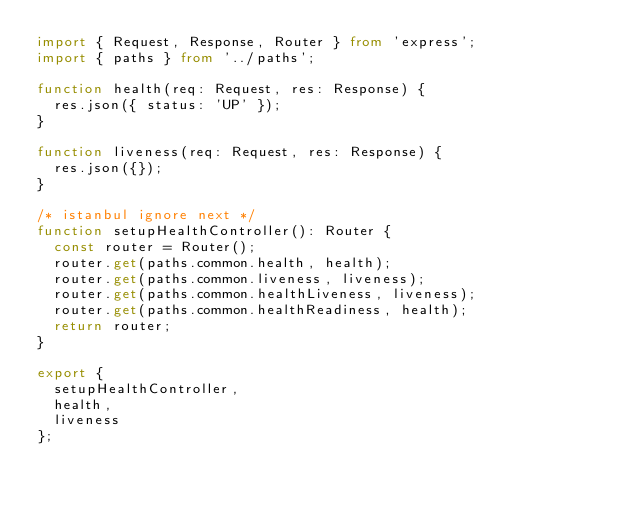Convert code to text. <code><loc_0><loc_0><loc_500><loc_500><_TypeScript_>import { Request, Response, Router } from 'express';
import { paths } from '../paths';

function health(req: Request, res: Response) {
  res.json({ status: 'UP' });
}

function liveness(req: Request, res: Response) {
  res.json({});
}

/* istanbul ignore next */
function setupHealthController(): Router {
  const router = Router();
  router.get(paths.common.health, health);
  router.get(paths.common.liveness, liveness);
  router.get(paths.common.healthLiveness, liveness);
  router.get(paths.common.healthReadiness, health);
  return router;
}

export {
  setupHealthController,
  health,
  liveness
};
</code> 